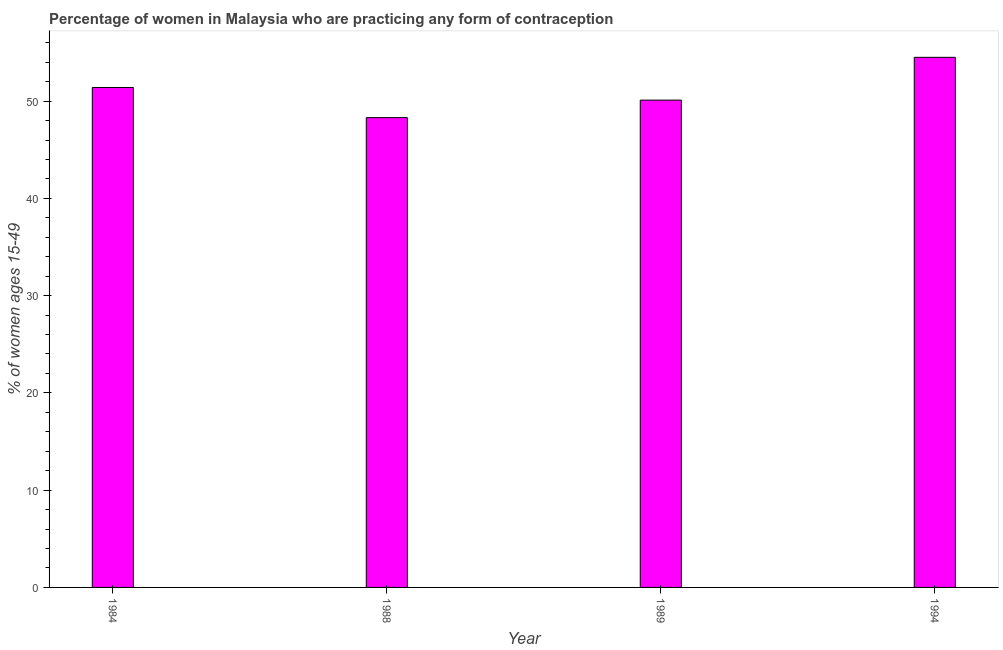Does the graph contain any zero values?
Your response must be concise. No. What is the title of the graph?
Provide a short and direct response. Percentage of women in Malaysia who are practicing any form of contraception. What is the label or title of the X-axis?
Provide a short and direct response. Year. What is the label or title of the Y-axis?
Keep it short and to the point. % of women ages 15-49. What is the contraceptive prevalence in 1988?
Keep it short and to the point. 48.3. Across all years, what is the maximum contraceptive prevalence?
Your answer should be compact. 54.5. Across all years, what is the minimum contraceptive prevalence?
Provide a short and direct response. 48.3. What is the sum of the contraceptive prevalence?
Your answer should be very brief. 204.3. What is the difference between the contraceptive prevalence in 1988 and 1989?
Offer a very short reply. -1.8. What is the average contraceptive prevalence per year?
Your response must be concise. 51.08. What is the median contraceptive prevalence?
Provide a short and direct response. 50.75. In how many years, is the contraceptive prevalence greater than 42 %?
Keep it short and to the point. 4. Do a majority of the years between 1984 and 1988 (inclusive) have contraceptive prevalence greater than 14 %?
Provide a succinct answer. Yes. What is the ratio of the contraceptive prevalence in 1988 to that in 1994?
Your answer should be very brief. 0.89. In how many years, is the contraceptive prevalence greater than the average contraceptive prevalence taken over all years?
Give a very brief answer. 2. What is the difference between two consecutive major ticks on the Y-axis?
Give a very brief answer. 10. Are the values on the major ticks of Y-axis written in scientific E-notation?
Make the answer very short. No. What is the % of women ages 15-49 in 1984?
Keep it short and to the point. 51.4. What is the % of women ages 15-49 of 1988?
Make the answer very short. 48.3. What is the % of women ages 15-49 in 1989?
Give a very brief answer. 50.1. What is the % of women ages 15-49 in 1994?
Make the answer very short. 54.5. What is the difference between the % of women ages 15-49 in 1984 and 1988?
Ensure brevity in your answer.  3.1. What is the difference between the % of women ages 15-49 in 1984 and 1989?
Ensure brevity in your answer.  1.3. What is the difference between the % of women ages 15-49 in 1984 and 1994?
Provide a short and direct response. -3.1. What is the difference between the % of women ages 15-49 in 1988 and 1989?
Offer a very short reply. -1.8. What is the difference between the % of women ages 15-49 in 1989 and 1994?
Provide a succinct answer. -4.4. What is the ratio of the % of women ages 15-49 in 1984 to that in 1988?
Your answer should be very brief. 1.06. What is the ratio of the % of women ages 15-49 in 1984 to that in 1989?
Ensure brevity in your answer.  1.03. What is the ratio of the % of women ages 15-49 in 1984 to that in 1994?
Offer a very short reply. 0.94. What is the ratio of the % of women ages 15-49 in 1988 to that in 1994?
Offer a terse response. 0.89. What is the ratio of the % of women ages 15-49 in 1989 to that in 1994?
Offer a terse response. 0.92. 